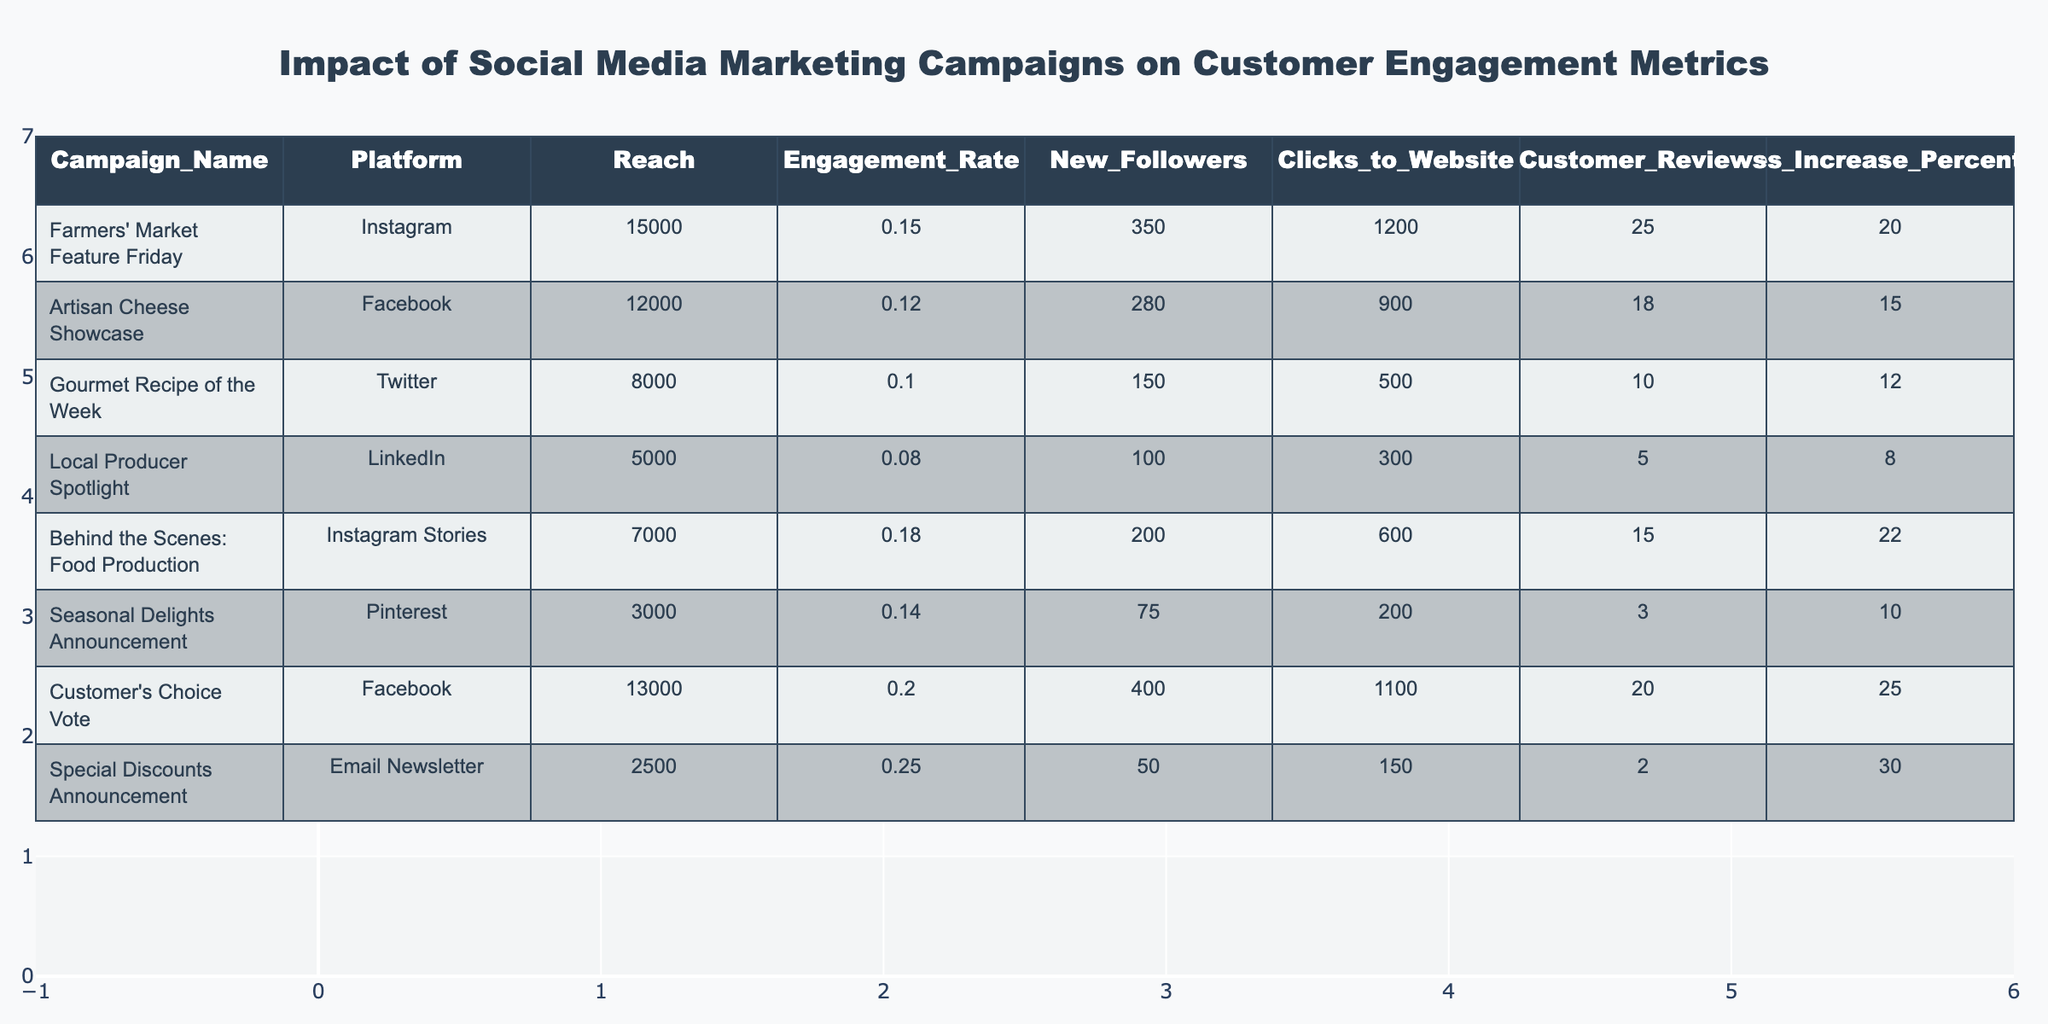What is the reach of the "Farmers' Market Feature Friday" campaign? The reach value for the "Farmers' Market Feature Friday" campaign is listed in the table as 15000.
Answer: 15000 Which campaign had the highest engagement rate? By comparing the engagement rates, the "Special Discounts Announcement" campaign has the highest engagement rate of 0.25.
Answer: 0.25 How many new followers were gained from the "Customer's Choice Vote" campaign? Looking at the table, the "Customer's Choice Vote" campaign resulted in gaining 400 new followers.
Answer: 400 What is the total increase in sales percentage for campaigns on Instagram? The campaigns on Instagram are "Farmers' Market Feature Friday" with 20%, and "Behind the Scenes: Food Production" with 22%. Adding these gives a total of 20 + 22 = 42%.
Answer: 42% Did the "Artisan Cheese Showcase" campaign result in more clicks to the website than the "Local Producer Spotlight"? Comparing the two campaigns, the "Artisan Cheese Showcase" resulted in 900 clicks, while the "Local Producer Spotlight" only resulted in 300 clicks. Therefore, the answer is yes, it resulted in more clicks.
Answer: Yes What is the average engagement rate of all campaigns across different platforms? The engagement rates of all campaigns are 0.15, 0.12, 0.10, 0.08, 0.18, 0.14, 0.20, 0.25. Summing these gives 0.15 + 0.12 + 0.10 + 0.08 + 0.18 + 0.14 + 0.20 + 0.25 = 1.12. Dividing by the number of campaigns (8) gives an average of 1.12 / 8 = 0.14.
Answer: 0.14 Which platform had the least reach among the campaigns listed? The smallest reach value in the table is for the "Seasonal Delights Announcement" campaign on Pinterest, which has a reach of 3000.
Answer: 3000 What percentage of customer reviews did the "Behind the Scenes: Food Production" campaign receive compared to the highest in the table? The highest number of customer reviews is from the "Farmers' Market Feature Friday" with 25 reviews. The "Behind the Scenes: Food Production" campaign received 15 reviews, so the percentage is (15 / 25) * 100 = 60%.
Answer: 60% What is the difference in new followers gained between the "Gourmet Recipe of the Week" and the "Special Discounts Announcement" campaigns? The "Gourmet Recipe of the Week" campaign gained 150 new followers, whereas the "Special Discounts Announcement" gained 50 new followers. The difference in new followers is 150 - 50 = 100.
Answer: 100 